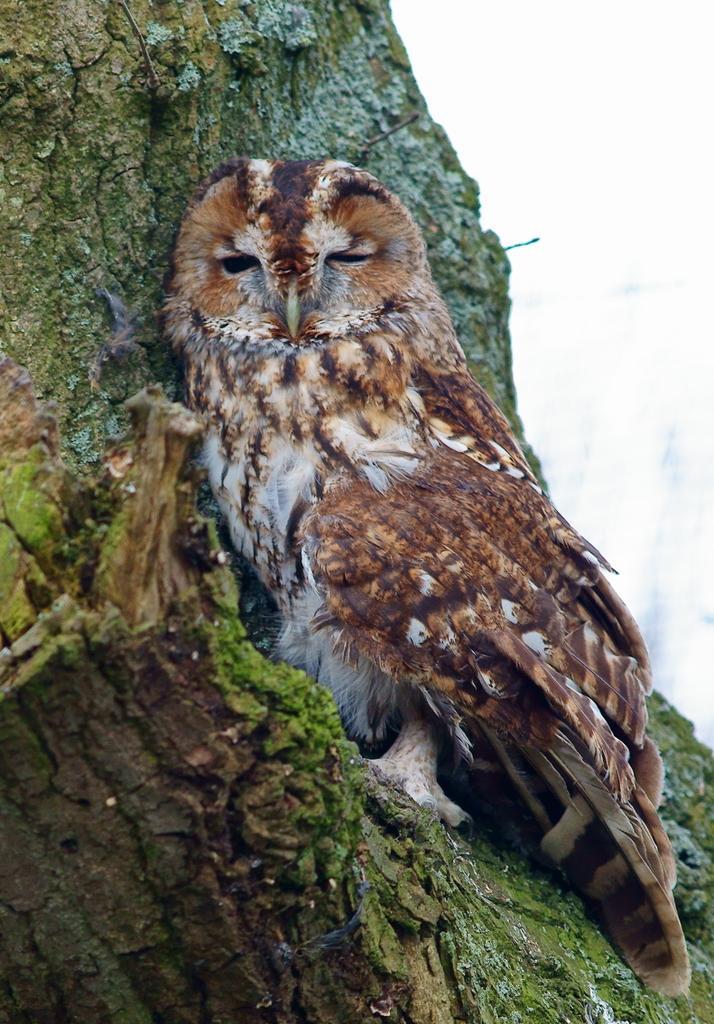Please provide a concise description of this image. In this image we can see an owl on the branch of a tree. 